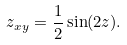<formula> <loc_0><loc_0><loc_500><loc_500>z _ { x y } = \frac { 1 } { 2 } \sin ( 2 z ) .</formula> 